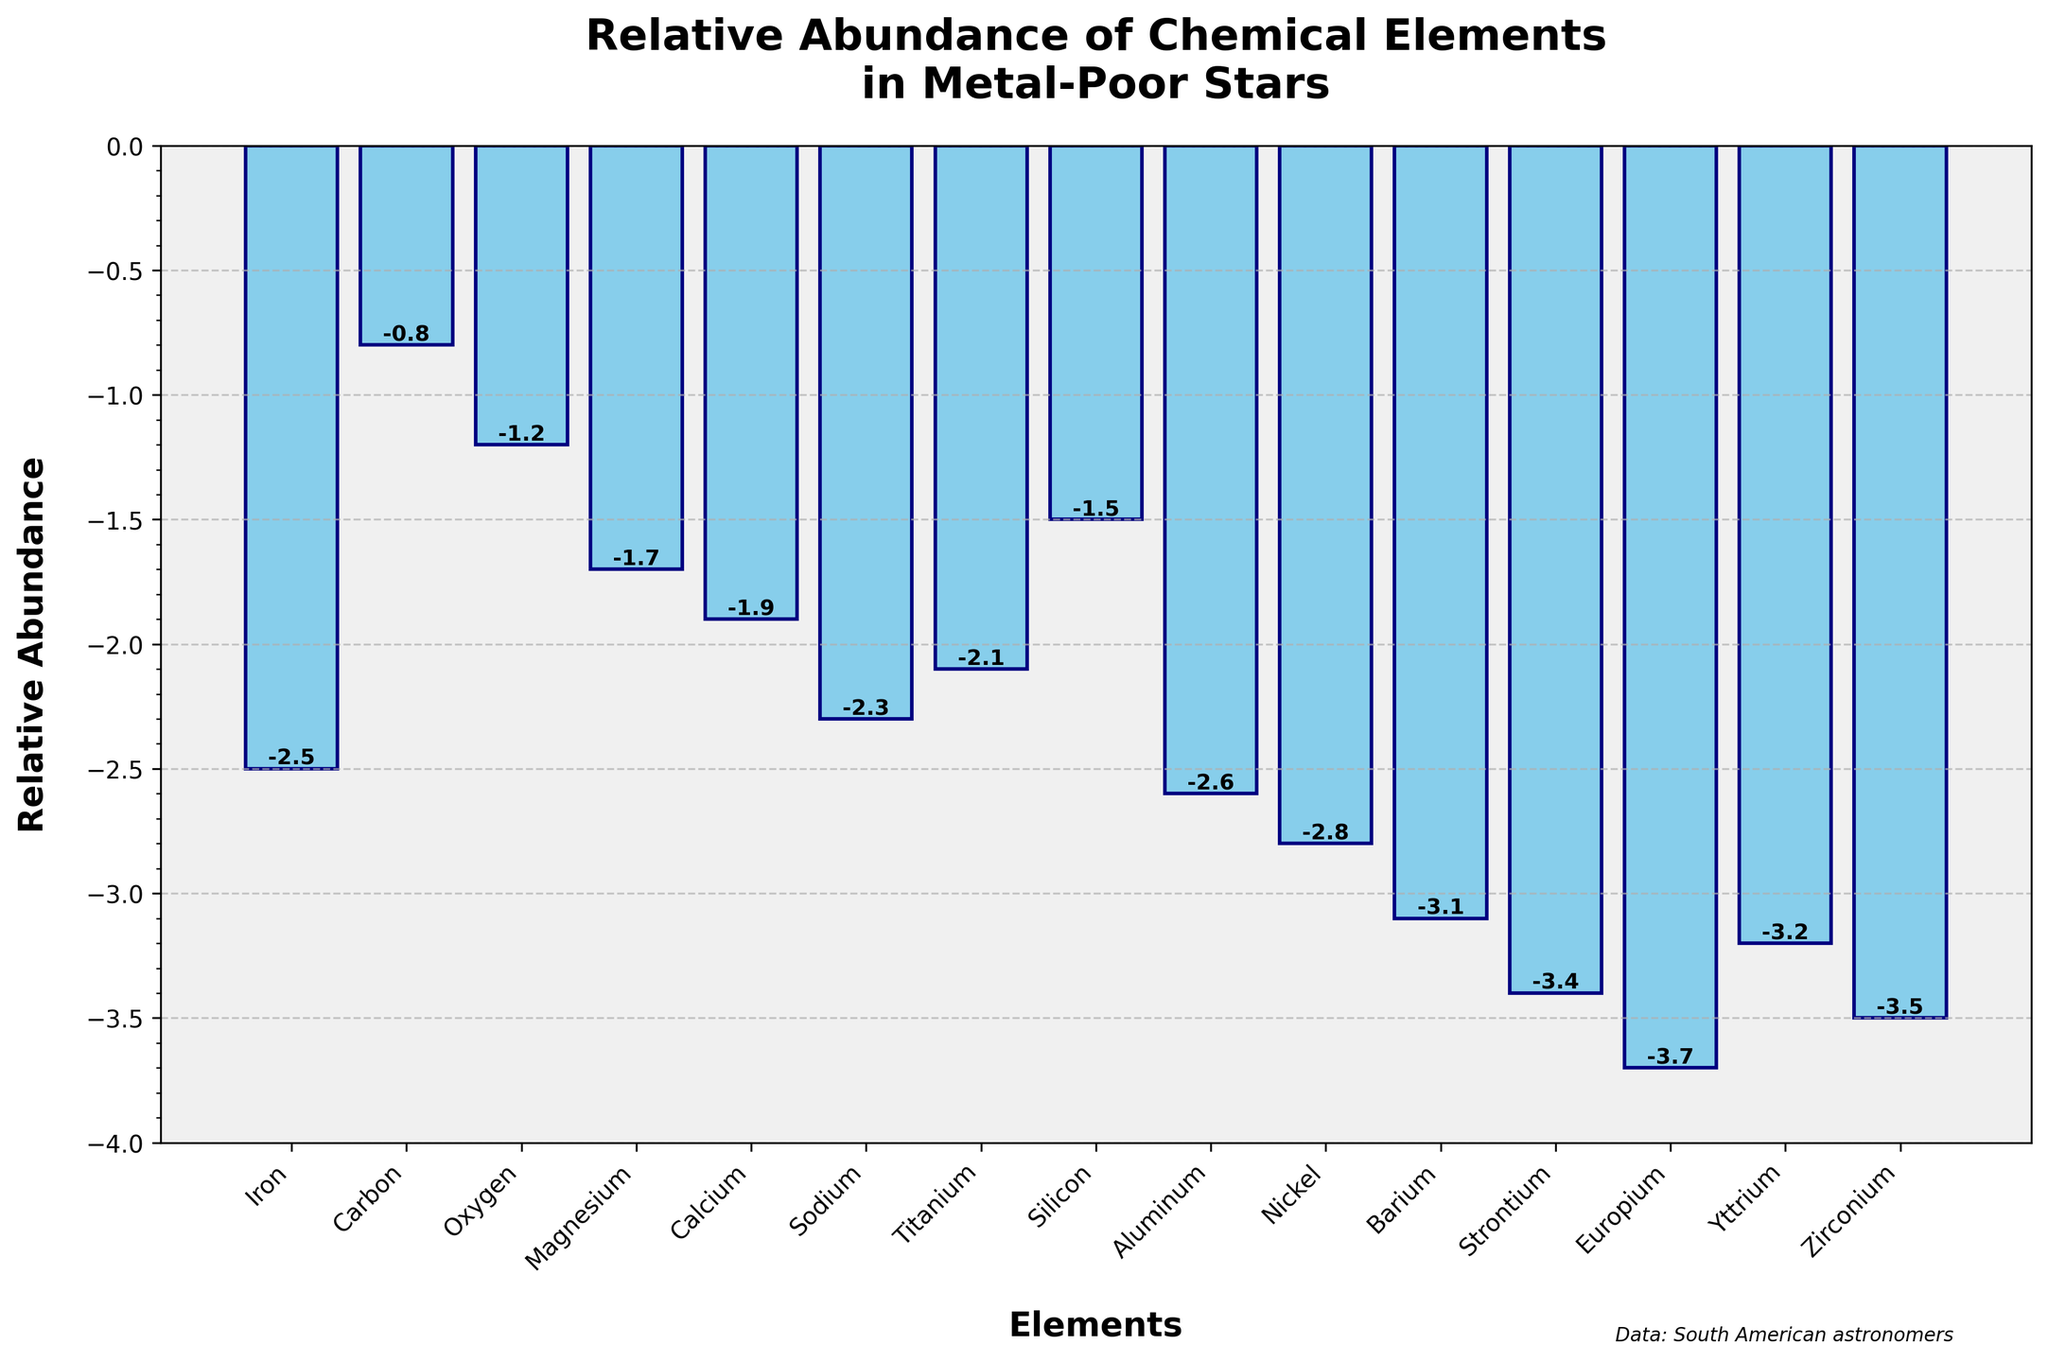what is the relative abundance of iron? The height of the bar corresponding to iron shows the relative abundance value. It states "-2.5".
Answer: -2.5 which element has the least relative abundance? By looking at the lowest bar in the plot, which represents the smallest value on the y-axis, we can observe the element with the least relative abundance. That element is Europium with -3.7.
Answer: Europium which two elements have the closest relative abundances? Comparing the heights of the bars for each element, the two elements with the closest values would have nearly equal bar heights. Here, Yttrium and Zirconium have a relative abundance of -3.2 and -3.5 respectively, making their values close.
Answer: Yttrium and Zirconium how much higher is the relative abundance of carbon compared to calcium? The relative abundance of carbon is -0.8, and for calcium, it is -1.9. To find the difference, subtract the calcium value from the carbon value: -0.8 - (-1.9) = 1.1.
Answer: 1.1 is there any element with a relative abundance greater than -1.0? By observing the heights of the bars, we need to look for any value greater than -1.0. Carbon has a relative abundance of -0.8, which is greater than -1.0.
Answer: Yes (Carbon) which element has a relative abundance closest to the median value of all given elements? To find the median, list all abundance values in ascending order and find the middle value. Ordered values: -3.7, -3.5, -3.4, -3.2, -3.1, -2.8, -2.6, -2.5, -2.3, -2.1, -1.9, -1.7, -1.5, -1.2, -0.8. The median value (middle value in the list) is -2.5. Iron has a relative abundance of -2.5, which is the median value.
Answer: Iron what is the average relative abundance of Magnesium and Silicon? The relative abundance values are -1.7 for Magnesium and -1.5 for Silicon. The average is calculated as (-1.7 + -1.5) / 2 = -1.6.
Answer: -1.6 how many elements have a relative abundance less than -3.0? By observing the heights of the bars, count the bars that fall below the -3.0 line. They are Barium, Strontium, Europium, and Yttrium. There are 4 such elements.
Answer: 4 which element shows a lower relative abundance: Sodium or Aluminium? Comparing the bar heights of Sodium and Aluminium, Sodium has -2.3, and Aluminium has -2.6. Since -2.6 is lower, Aluminium shows a lower relative abundance.
Answer: Aluminium 